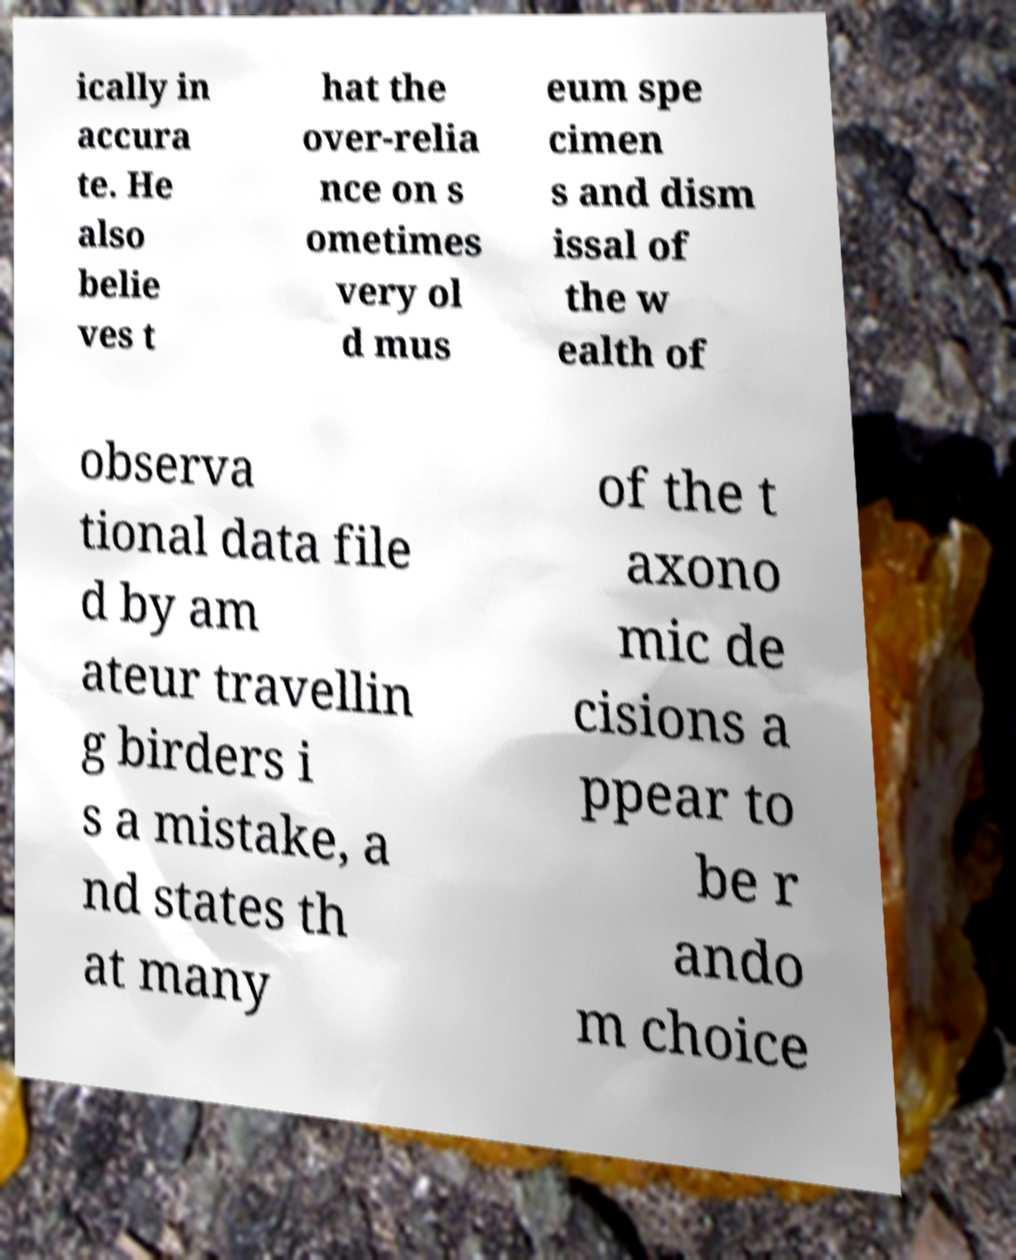Please identify and transcribe the text found in this image. ically in accura te. He also belie ves t hat the over-relia nce on s ometimes very ol d mus eum spe cimen s and dism issal of the w ealth of observa tional data file d by am ateur travellin g birders i s a mistake, a nd states th at many of the t axono mic de cisions a ppear to be r ando m choice 